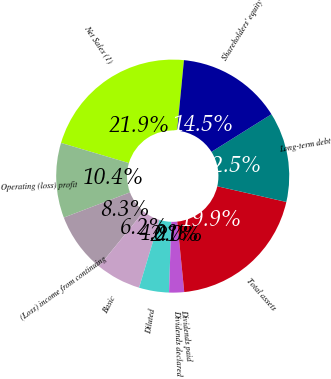<chart> <loc_0><loc_0><loc_500><loc_500><pie_chart><fcel>Net Sales (1)<fcel>Operating (loss) profit<fcel>(Loss) income from continuing<fcel>Basic<fcel>Diluted<fcel>Dividends declared<fcel>Dividends paid<fcel>Total assets<fcel>Long-term debt<fcel>Shareholders' equity<nl><fcel>21.94%<fcel>10.39%<fcel>8.31%<fcel>6.24%<fcel>4.16%<fcel>2.08%<fcel>0.0%<fcel>19.86%<fcel>12.47%<fcel>14.55%<nl></chart> 